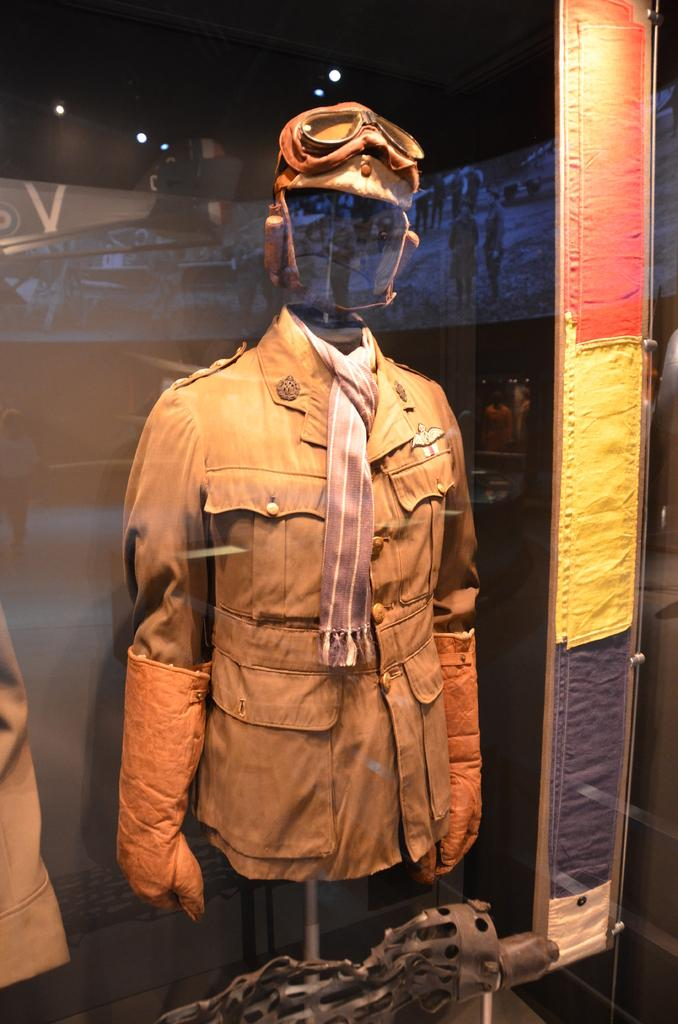What is visible through the glass in the image? There is a stand behind the glass in the image. What items can be seen on the stand? The stand holds a jacket, style, gloves, and goggles. What is the purpose of the glass in the image? The glass allows for a reflection of objects on its surface. How many seeds can be seen growing in the jar in the image? There is no jar or seeds present in the image. What is the level of quietness in the image? The concept of quietness cannot be determined from the image, as it does not convey any auditory information. 